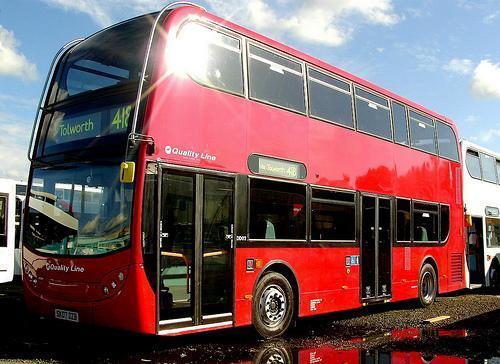How many stories do these buses have?
Give a very brief answer. 2. 